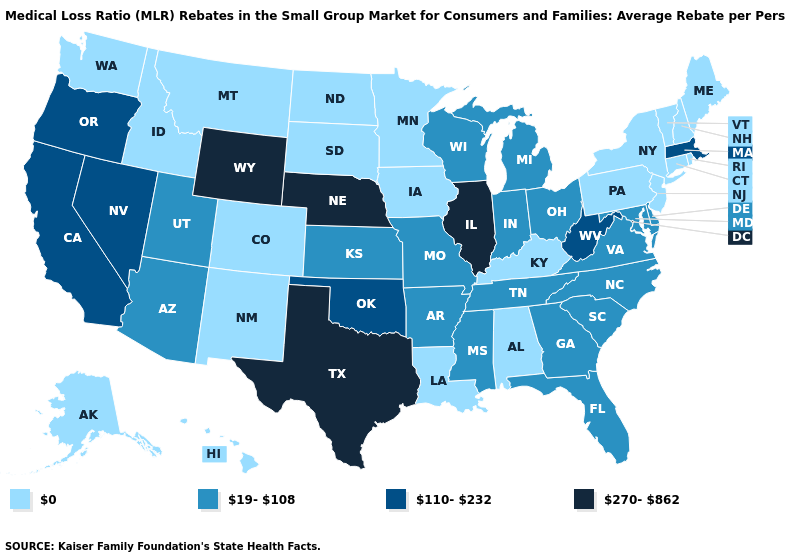What is the value of Maryland?
Write a very short answer. 19-108. Does Idaho have the lowest value in the USA?
Short answer required. Yes. Name the states that have a value in the range 270-862?
Give a very brief answer. Illinois, Nebraska, Texas, Wyoming. Among the states that border Wyoming , which have the highest value?
Keep it brief. Nebraska. What is the value of Virginia?
Short answer required. 19-108. Name the states that have a value in the range 270-862?
Short answer required. Illinois, Nebraska, Texas, Wyoming. Does California have the lowest value in the West?
Answer briefly. No. Name the states that have a value in the range 110-232?
Be succinct. California, Massachusetts, Nevada, Oklahoma, Oregon, West Virginia. Is the legend a continuous bar?
Keep it brief. No. What is the value of New York?
Short answer required. 0. Name the states that have a value in the range 19-108?
Quick response, please. Arizona, Arkansas, Delaware, Florida, Georgia, Indiana, Kansas, Maryland, Michigan, Mississippi, Missouri, North Carolina, Ohio, South Carolina, Tennessee, Utah, Virginia, Wisconsin. What is the value of Michigan?
Answer briefly. 19-108. Does Indiana have the lowest value in the USA?
Answer briefly. No. What is the value of Kansas?
Give a very brief answer. 19-108. Does the first symbol in the legend represent the smallest category?
Write a very short answer. Yes. 